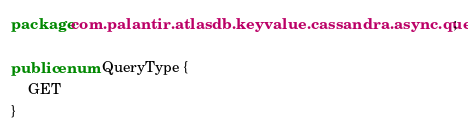Convert code to text. <code><loc_0><loc_0><loc_500><loc_500><_Java_>
package com.palantir.atlasdb.keyvalue.cassandra.async.queries;

public enum QueryType {
    GET
}
</code> 